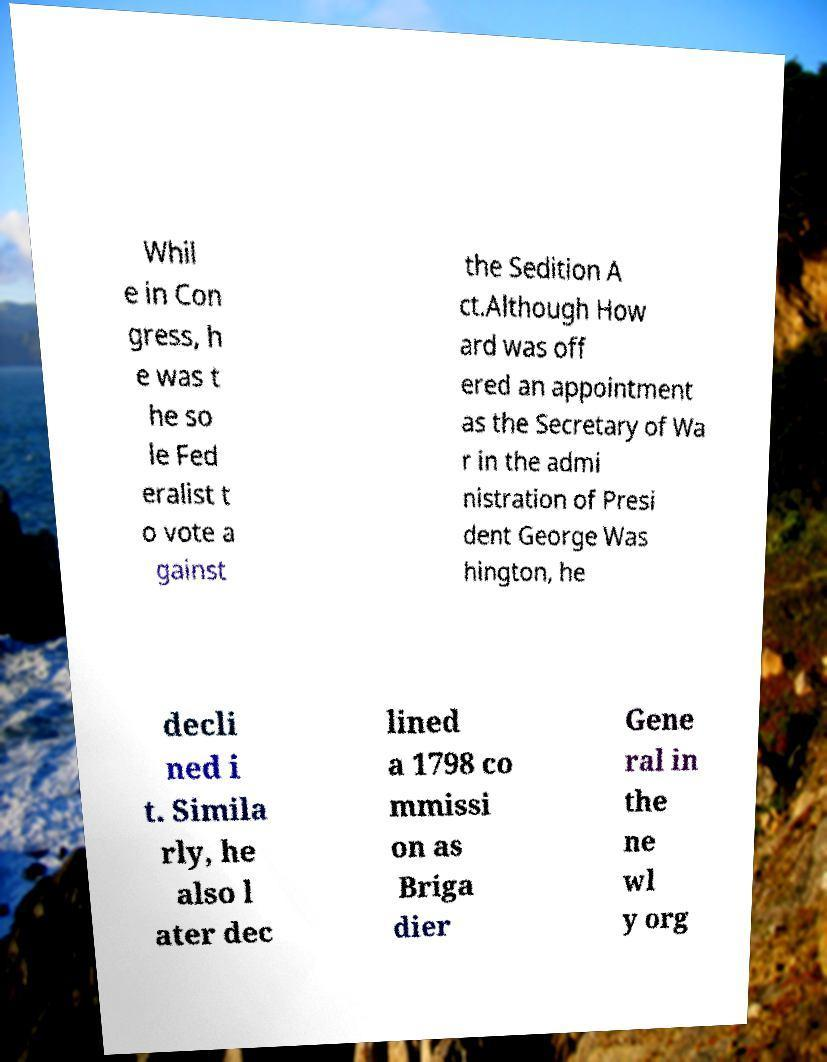Can you accurately transcribe the text from the provided image for me? Whil e in Con gress, h e was t he so le Fed eralist t o vote a gainst the Sedition A ct.Although How ard was off ered an appointment as the Secretary of Wa r in the admi nistration of Presi dent George Was hington, he decli ned i t. Simila rly, he also l ater dec lined a 1798 co mmissi on as Briga dier Gene ral in the ne wl y org 